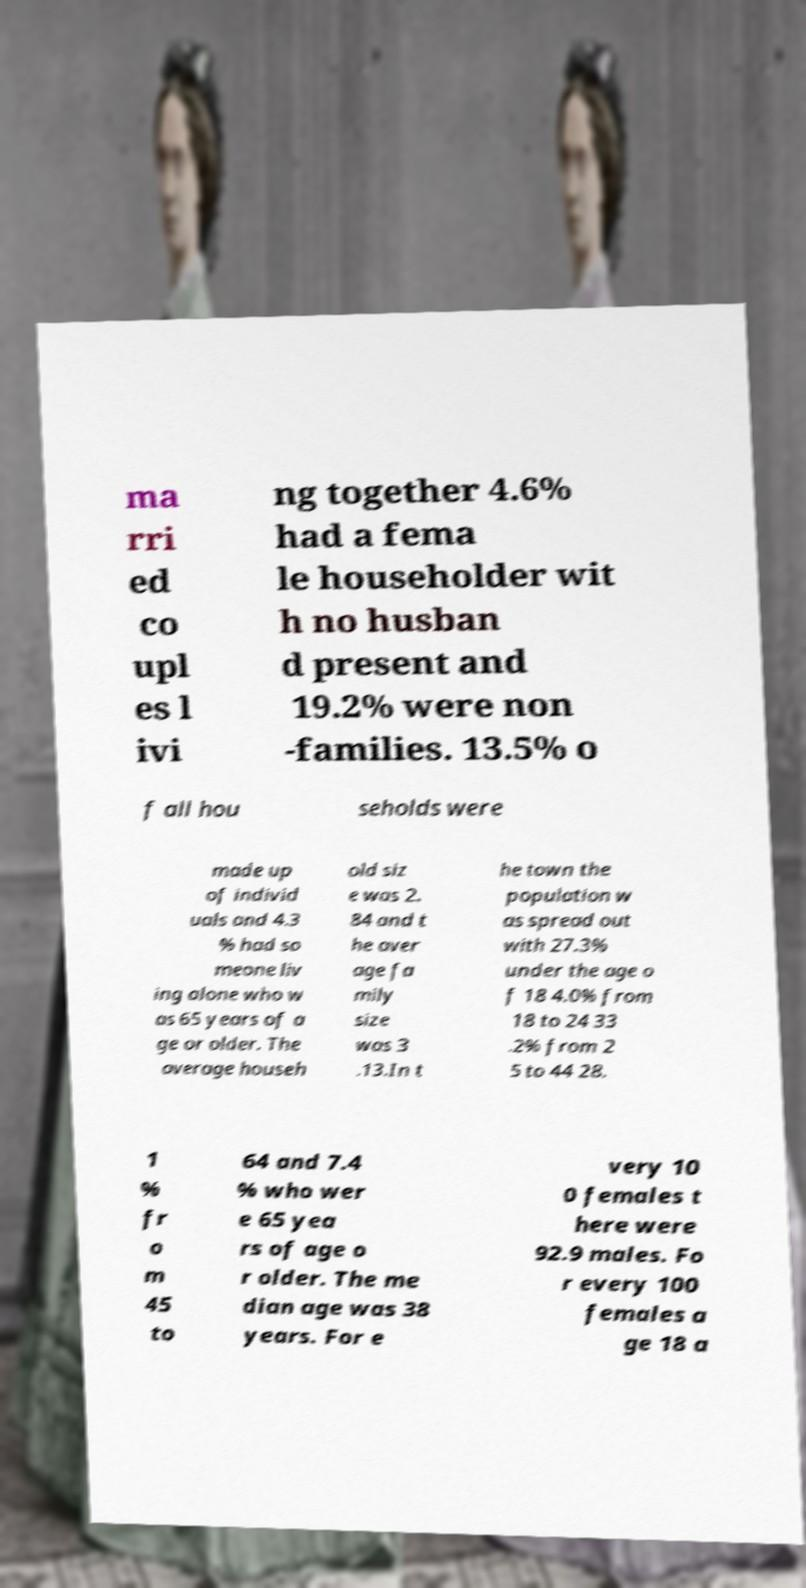I need the written content from this picture converted into text. Can you do that? ma rri ed co upl es l ivi ng together 4.6% had a fema le householder wit h no husban d present and 19.2% were non -families. 13.5% o f all hou seholds were made up of individ uals and 4.3 % had so meone liv ing alone who w as 65 years of a ge or older. The average househ old siz e was 2. 84 and t he aver age fa mily size was 3 .13.In t he town the population w as spread out with 27.3% under the age o f 18 4.0% from 18 to 24 33 .2% from 2 5 to 44 28. 1 % fr o m 45 to 64 and 7.4 % who wer e 65 yea rs of age o r older. The me dian age was 38 years. For e very 10 0 females t here were 92.9 males. Fo r every 100 females a ge 18 a 